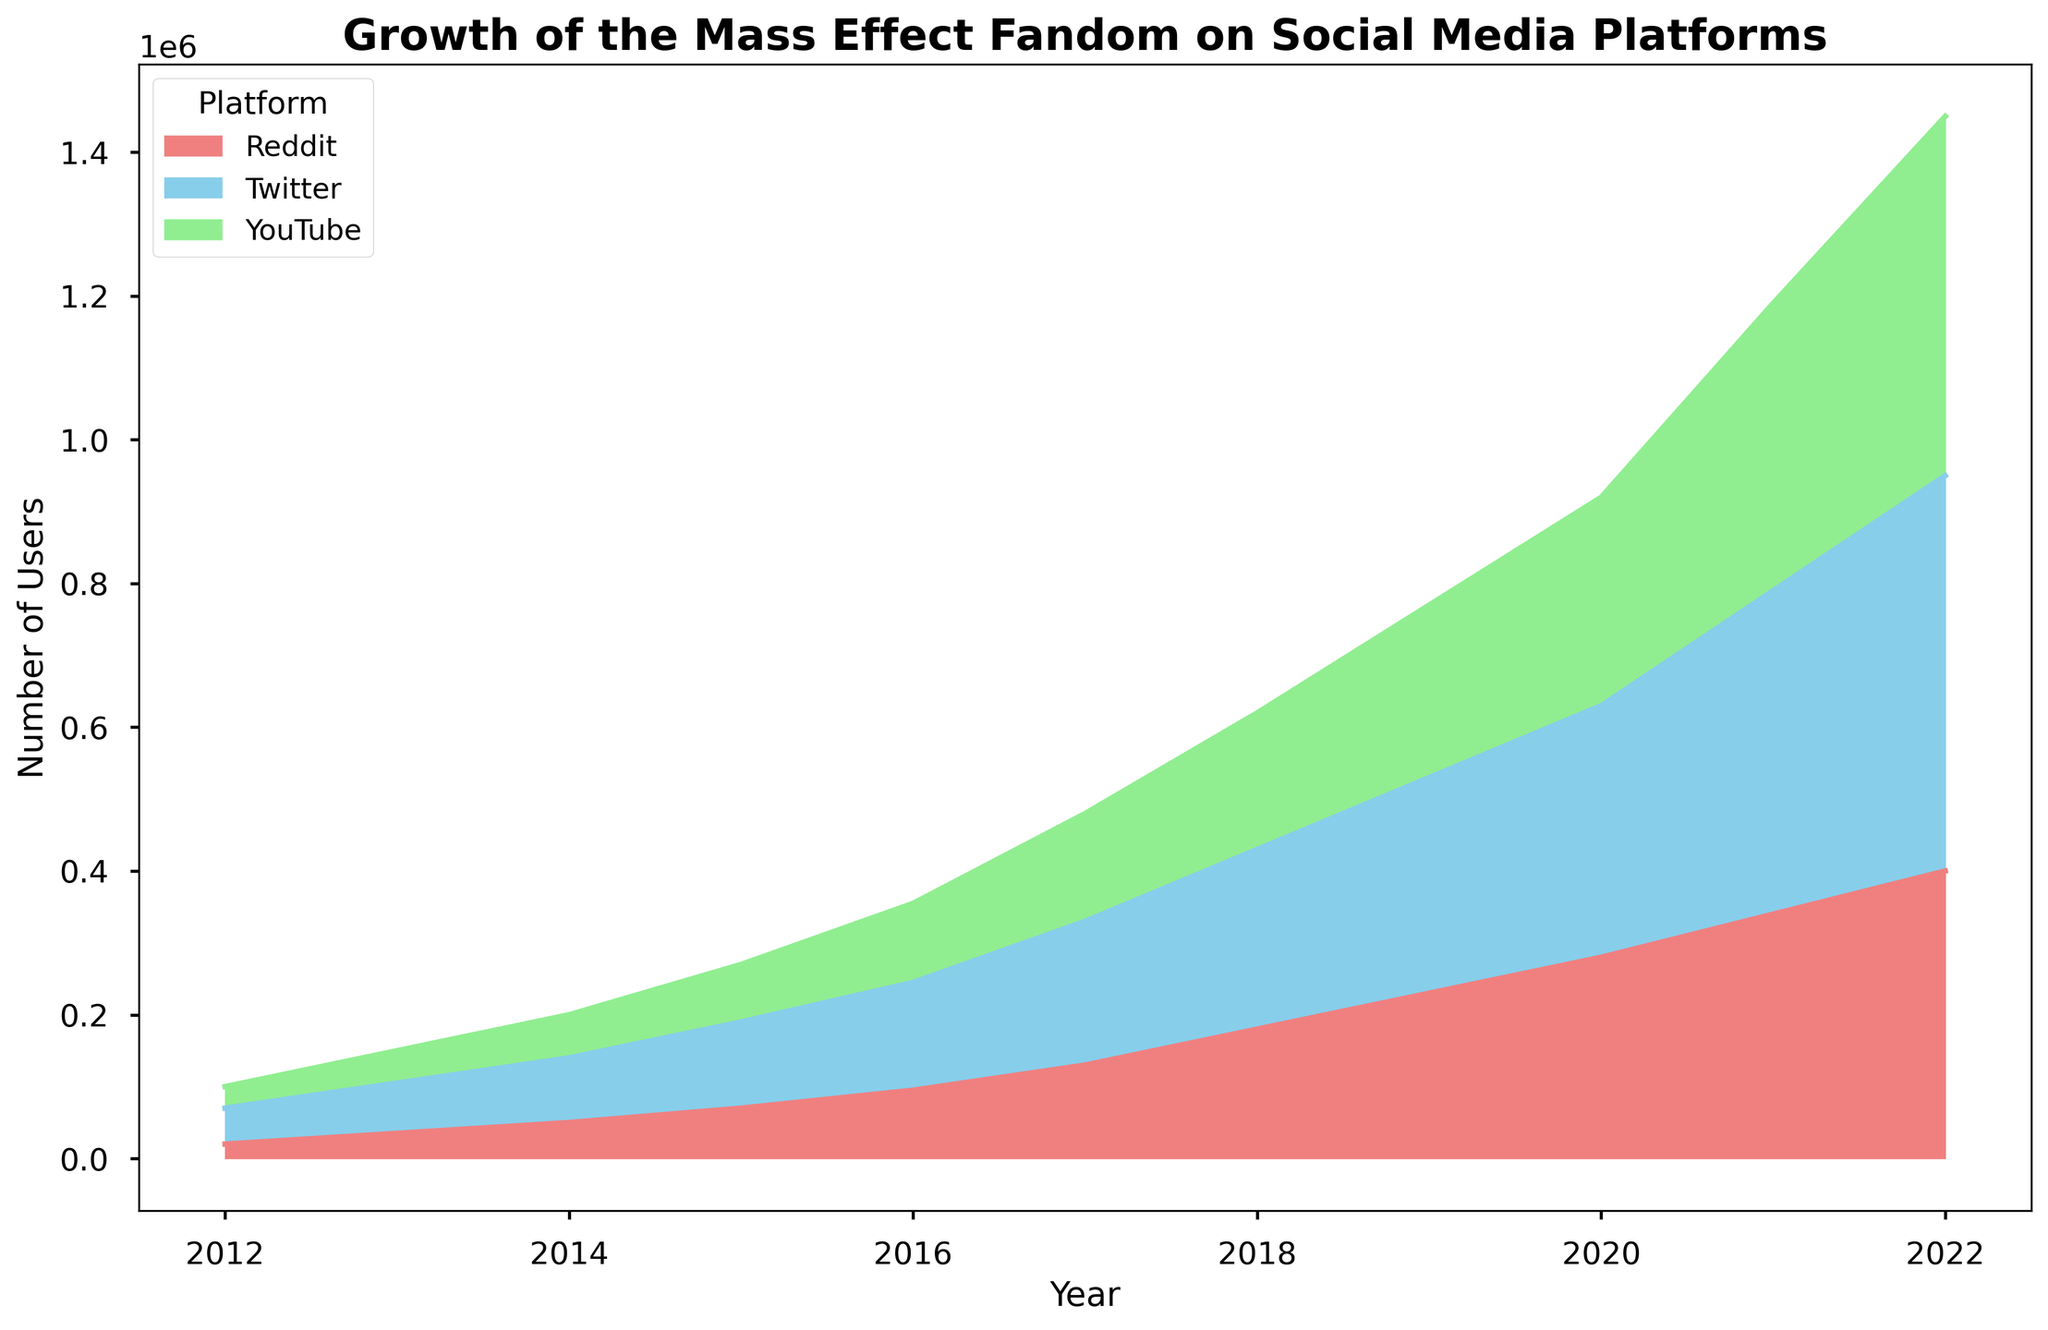What is the trend for the number of Twitter users from 2012 to 2022? Start from the lowest point in 2012, observe the consistent increase each year, and end at the highest point in 2022. The number is rising year by year.
Answer: Steady increase Which platform showed the highest growth in users from 2012 to 2022? Compare the values for Twitter, Reddit, and YouTube in 2012 and 2022. Calculate the increase for each platform (Twitter: 500,000, Reddit: 380,000, YouTube: 470,000). Twitter had the highest growth.
Answer: Twitter By how much did the total number of users increase on all platforms combined in 2017 compared to 2013? Sum the users for Twitter, Reddit, and YouTube in 2017 and in 2013. The total for 2017 is 480,000, and for 2013 is 150,000. The increase is 480,000 - 150,000 = 330,000.
Answer: 330,000 Which platform had the least number of users in the year 2016? Compare the values for Twitter, Reddit, and YouTube in 2016. The number of users for Reddit in 2016 is 95,000 which is lower than Twitter and YouTube.
Answer: Reddit In 2021, which platform had the highest number of users and by how much did it surpass the one with the third-highest number of users? Compare the values for Twitter, Reddit, and YouTube in 2021. The users for YouTube were highest (400,000). The difference between YouTube (400,000) and Reddit (340,000) is 60,000.
Answer: YouTube, 60,000 What is the average number of users on Reddit across all the years provided? Sum all the Reddit users from 2012 to 2022 (20,000 + 35,000 + 50,000 + 70,000 + 95,000 + 130,000 + 180,000 + 230,000 + 280,000 + 340,000 + 400,000 = 1830,000). Divide this sum by the number of years (11). The average is 1830,000 / 11 ≈ 166,364.
Answer: 166,364 In what year did YouTube surpass 300,000 users? Look at the values for YouTube each year and identify the first instance where the number is greater than 300,000. This happens in 2020 with 290,000 users, so it surpasses 300,000 in 2021.
Answer: 2021 